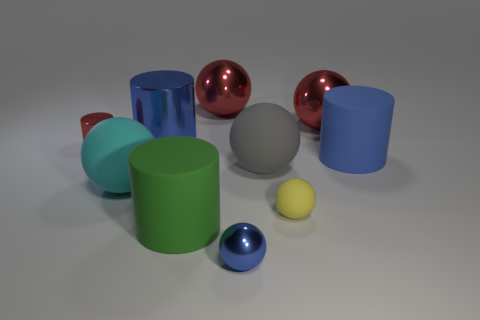Is there a pattern in the arrangement of the objects? There does not appear to be a deliberate pattern, but the objects are arranged in a way that demonstrates a variety of sizes, colors, and textures, possibly to showcase contrast and diversity in their properties. 